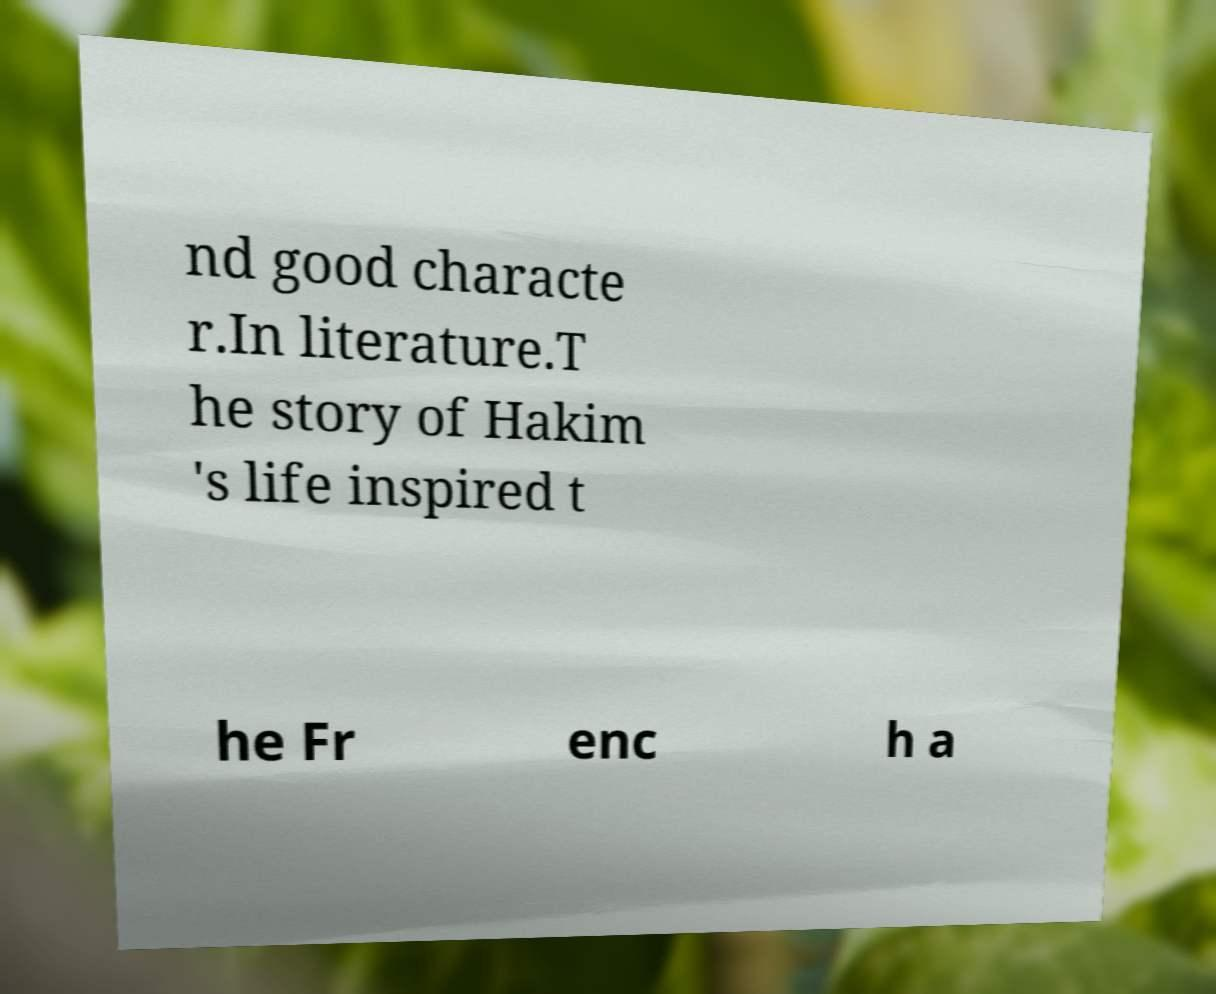There's text embedded in this image that I need extracted. Can you transcribe it verbatim? nd good characte r.In literature.T he story of Hakim 's life inspired t he Fr enc h a 